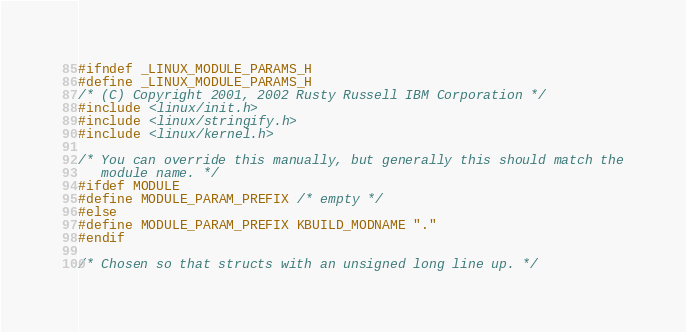Convert code to text. <code><loc_0><loc_0><loc_500><loc_500><_C_>#ifndef _LINUX_MODULE_PARAMS_H
#define _LINUX_MODULE_PARAMS_H
/* (C) Copyright 2001, 2002 Rusty Russell IBM Corporation */
#include <linux/init.h>
#include <linux/stringify.h>
#include <linux/kernel.h>

/* You can override this manually, but generally this should match the
   module name. */
#ifdef MODULE
#define MODULE_PARAM_PREFIX /* empty */
#else
#define MODULE_PARAM_PREFIX KBUILD_MODNAME "."
#endif

/* Chosen so that structs with an unsigned long line up. */</code> 